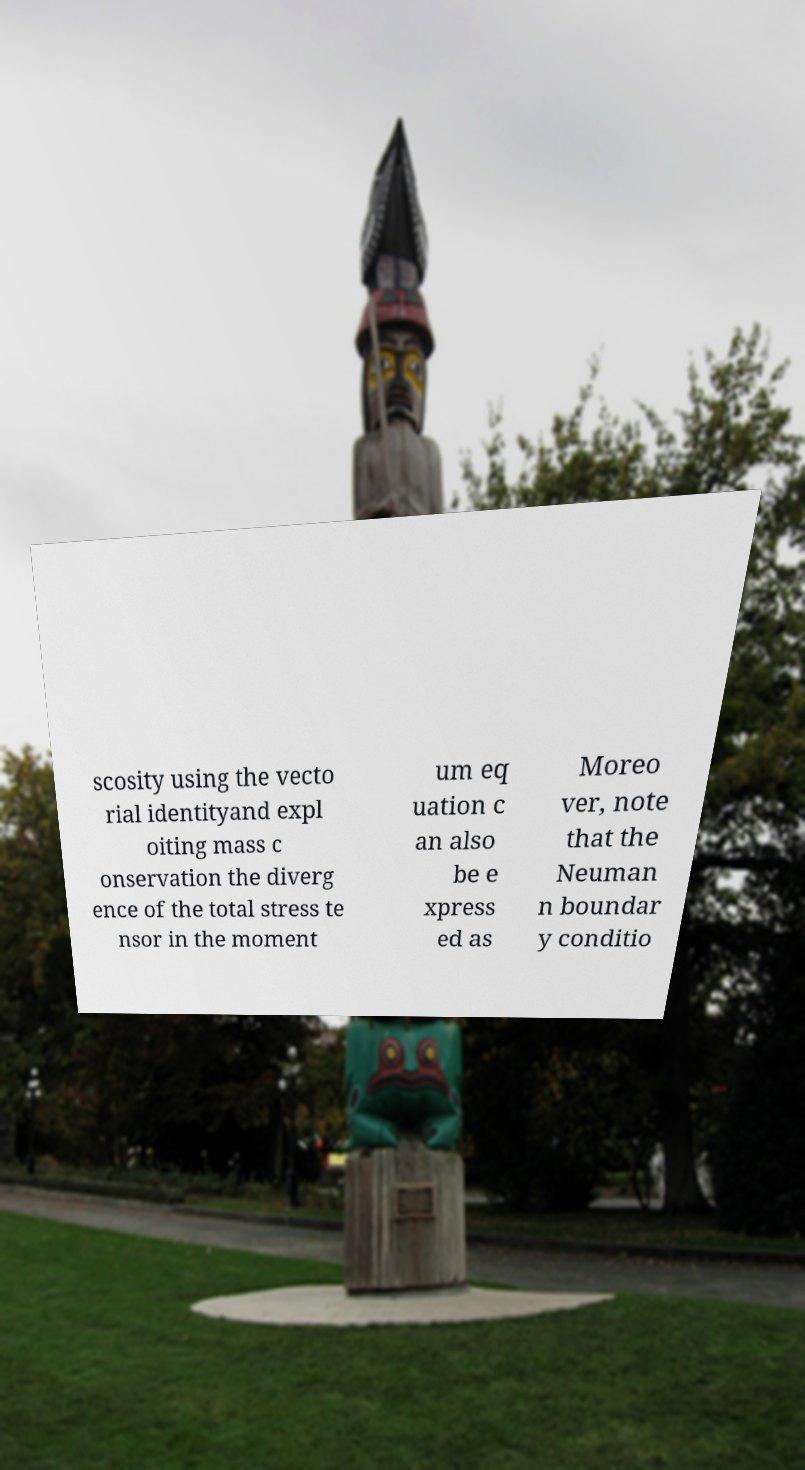Can you accurately transcribe the text from the provided image for me? scosity using the vecto rial identityand expl oiting mass c onservation the diverg ence of the total stress te nsor in the moment um eq uation c an also be e xpress ed as Moreo ver, note that the Neuman n boundar y conditio 